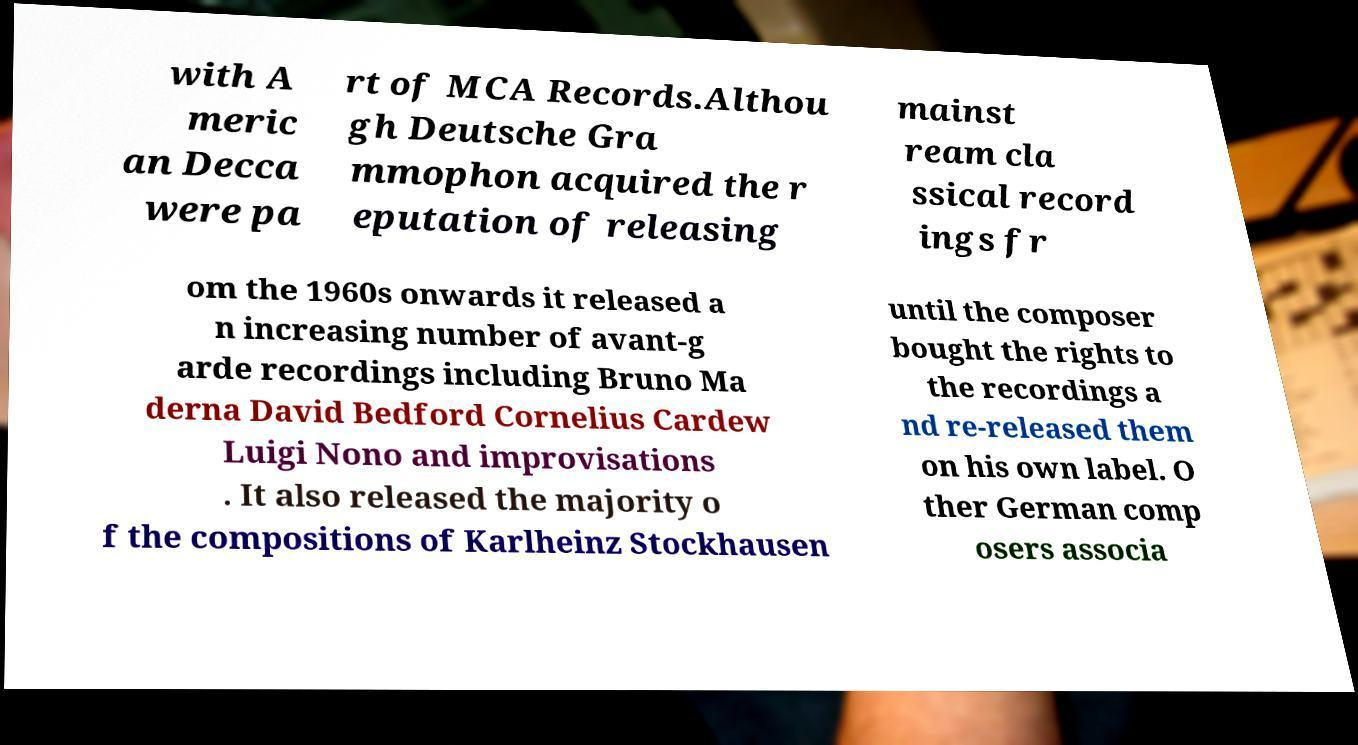Can you accurately transcribe the text from the provided image for me? with A meric an Decca were pa rt of MCA Records.Althou gh Deutsche Gra mmophon acquired the r eputation of releasing mainst ream cla ssical record ings fr om the 1960s onwards it released a n increasing number of avant-g arde recordings including Bruno Ma derna David Bedford Cornelius Cardew Luigi Nono and improvisations . It also released the majority o f the compositions of Karlheinz Stockhausen until the composer bought the rights to the recordings a nd re-released them on his own label. O ther German comp osers associa 